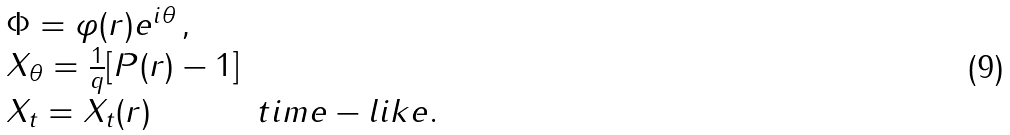Convert formula to latex. <formula><loc_0><loc_0><loc_500><loc_500>\begin{array} { l l } \Phi = \varphi ( r ) e ^ { i \theta } \, , \\ X _ { \theta } = \frac { 1 } { q } [ P ( r ) - 1 ] & \\ X _ { t } = X _ { t } ( r ) & t i m e - l i k e . \end{array}</formula> 